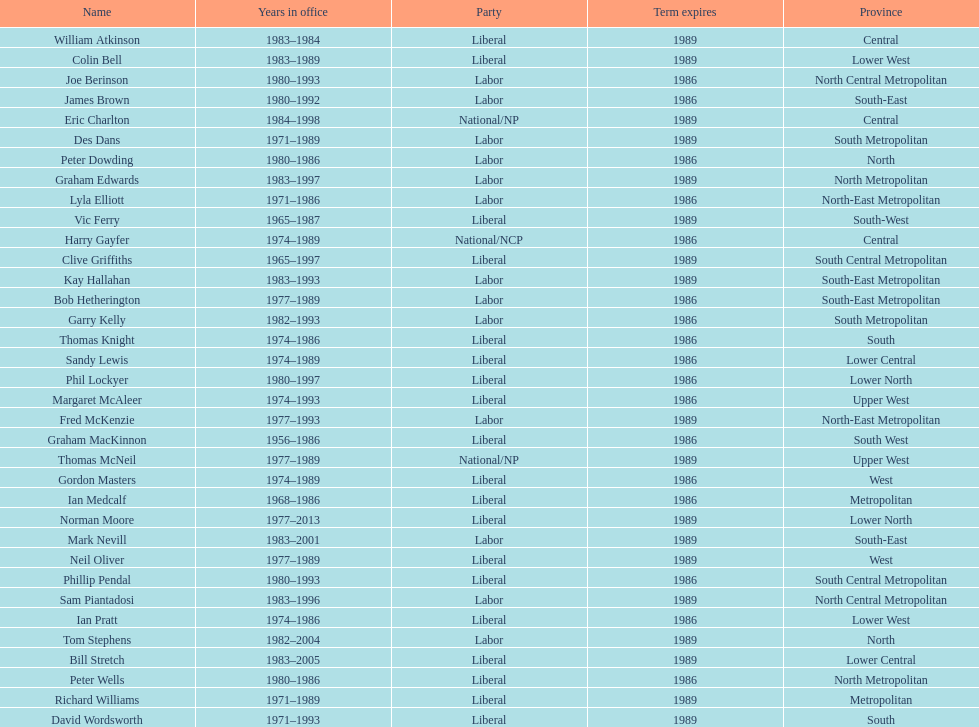What is the number of people in the liberal party? 19. 